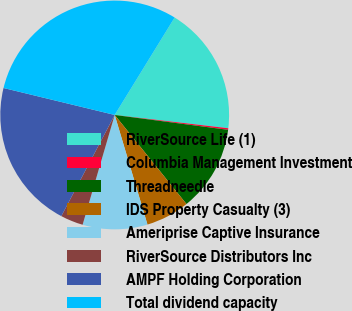Convert chart to OTSL. <chart><loc_0><loc_0><loc_500><loc_500><pie_chart><fcel>RiverSource Life (1)<fcel>Columbia Management Investment<fcel>Threadneedle<fcel>IDS Property Casualty (3)<fcel>Ameriprise Captive Insurance<fcel>RiverSource Distributors Inc<fcel>AMPF Holding Corporation<fcel>Total dividend capacity<nl><fcel>18.08%<fcel>0.22%<fcel>12.13%<fcel>6.17%<fcel>9.15%<fcel>3.2%<fcel>21.06%<fcel>29.99%<nl></chart> 